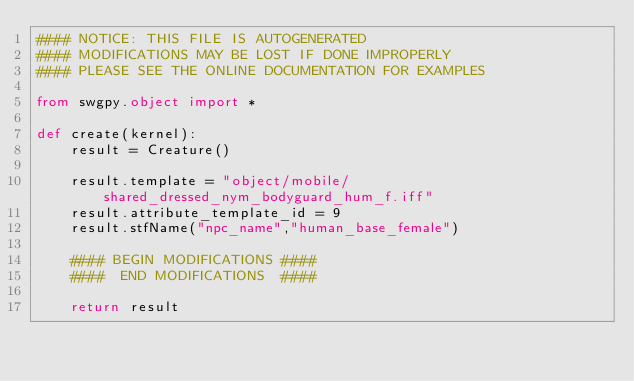Convert code to text. <code><loc_0><loc_0><loc_500><loc_500><_Python_>#### NOTICE: THIS FILE IS AUTOGENERATED
#### MODIFICATIONS MAY BE LOST IF DONE IMPROPERLY
#### PLEASE SEE THE ONLINE DOCUMENTATION FOR EXAMPLES

from swgpy.object import *	

def create(kernel):
	result = Creature()

	result.template = "object/mobile/shared_dressed_nym_bodyguard_hum_f.iff"
	result.attribute_template_id = 9
	result.stfName("npc_name","human_base_female")		
	
	#### BEGIN MODIFICATIONS ####
	####  END MODIFICATIONS  ####
	
	return result</code> 